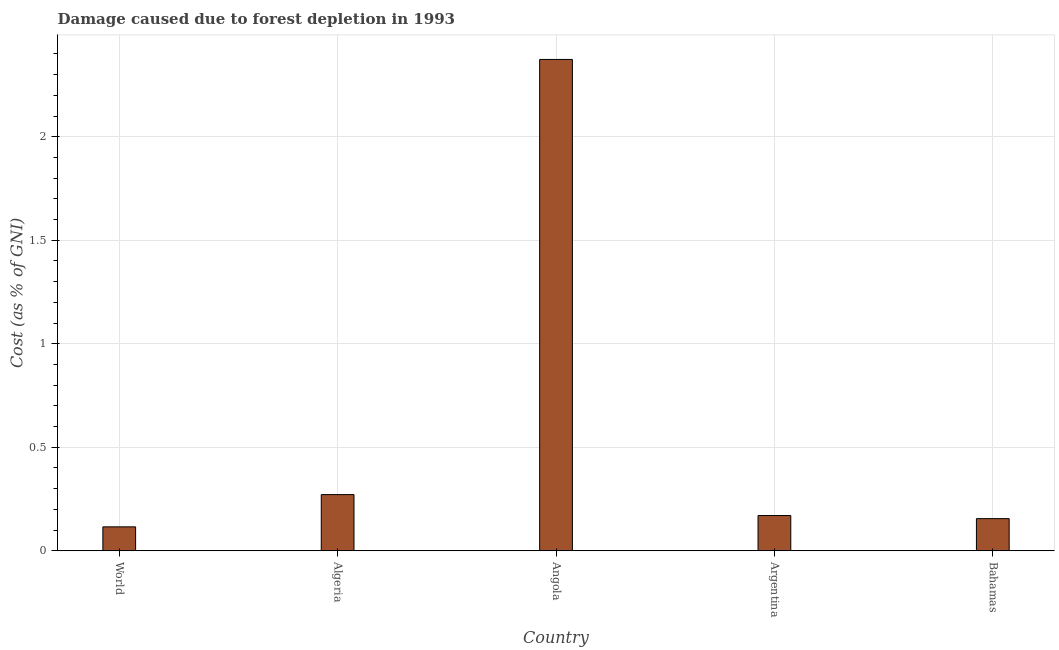Does the graph contain grids?
Your answer should be very brief. Yes. What is the title of the graph?
Give a very brief answer. Damage caused due to forest depletion in 1993. What is the label or title of the X-axis?
Your answer should be compact. Country. What is the label or title of the Y-axis?
Ensure brevity in your answer.  Cost (as % of GNI). What is the damage caused due to forest depletion in Angola?
Your answer should be compact. 2.37. Across all countries, what is the maximum damage caused due to forest depletion?
Provide a short and direct response. 2.37. Across all countries, what is the minimum damage caused due to forest depletion?
Provide a succinct answer. 0.12. In which country was the damage caused due to forest depletion maximum?
Your answer should be very brief. Angola. In which country was the damage caused due to forest depletion minimum?
Keep it short and to the point. World. What is the sum of the damage caused due to forest depletion?
Make the answer very short. 3.09. What is the difference between the damage caused due to forest depletion in Angola and Bahamas?
Your answer should be compact. 2.22. What is the average damage caused due to forest depletion per country?
Provide a short and direct response. 0.62. What is the median damage caused due to forest depletion?
Ensure brevity in your answer.  0.17. In how many countries, is the damage caused due to forest depletion greater than 2.2 %?
Give a very brief answer. 1. What is the ratio of the damage caused due to forest depletion in Algeria to that in Argentina?
Provide a succinct answer. 1.59. Is the damage caused due to forest depletion in Argentina less than that in World?
Offer a terse response. No. What is the difference between the highest and the second highest damage caused due to forest depletion?
Your response must be concise. 2.1. What is the difference between the highest and the lowest damage caused due to forest depletion?
Offer a terse response. 2.26. How many bars are there?
Keep it short and to the point. 5. How many countries are there in the graph?
Ensure brevity in your answer.  5. Are the values on the major ticks of Y-axis written in scientific E-notation?
Your answer should be very brief. No. What is the Cost (as % of GNI) of World?
Make the answer very short. 0.12. What is the Cost (as % of GNI) in Algeria?
Offer a very short reply. 0.27. What is the Cost (as % of GNI) of Angola?
Provide a short and direct response. 2.37. What is the Cost (as % of GNI) in Argentina?
Provide a short and direct response. 0.17. What is the Cost (as % of GNI) in Bahamas?
Your response must be concise. 0.16. What is the difference between the Cost (as % of GNI) in World and Algeria?
Ensure brevity in your answer.  -0.16. What is the difference between the Cost (as % of GNI) in World and Angola?
Your answer should be compact. -2.26. What is the difference between the Cost (as % of GNI) in World and Argentina?
Provide a short and direct response. -0.05. What is the difference between the Cost (as % of GNI) in World and Bahamas?
Your answer should be very brief. -0.04. What is the difference between the Cost (as % of GNI) in Algeria and Angola?
Keep it short and to the point. -2.1. What is the difference between the Cost (as % of GNI) in Algeria and Argentina?
Provide a succinct answer. 0.1. What is the difference between the Cost (as % of GNI) in Algeria and Bahamas?
Offer a very short reply. 0.12. What is the difference between the Cost (as % of GNI) in Angola and Argentina?
Make the answer very short. 2.2. What is the difference between the Cost (as % of GNI) in Angola and Bahamas?
Offer a terse response. 2.22. What is the difference between the Cost (as % of GNI) in Argentina and Bahamas?
Your answer should be very brief. 0.01. What is the ratio of the Cost (as % of GNI) in World to that in Algeria?
Make the answer very short. 0.43. What is the ratio of the Cost (as % of GNI) in World to that in Angola?
Provide a succinct answer. 0.05. What is the ratio of the Cost (as % of GNI) in World to that in Argentina?
Make the answer very short. 0.68. What is the ratio of the Cost (as % of GNI) in World to that in Bahamas?
Provide a succinct answer. 0.74. What is the ratio of the Cost (as % of GNI) in Algeria to that in Angola?
Make the answer very short. 0.11. What is the ratio of the Cost (as % of GNI) in Algeria to that in Argentina?
Give a very brief answer. 1.59. What is the ratio of the Cost (as % of GNI) in Algeria to that in Bahamas?
Keep it short and to the point. 1.75. What is the ratio of the Cost (as % of GNI) in Angola to that in Argentina?
Your response must be concise. 13.94. What is the ratio of the Cost (as % of GNI) in Angola to that in Bahamas?
Provide a succinct answer. 15.29. What is the ratio of the Cost (as % of GNI) in Argentina to that in Bahamas?
Give a very brief answer. 1.1. 